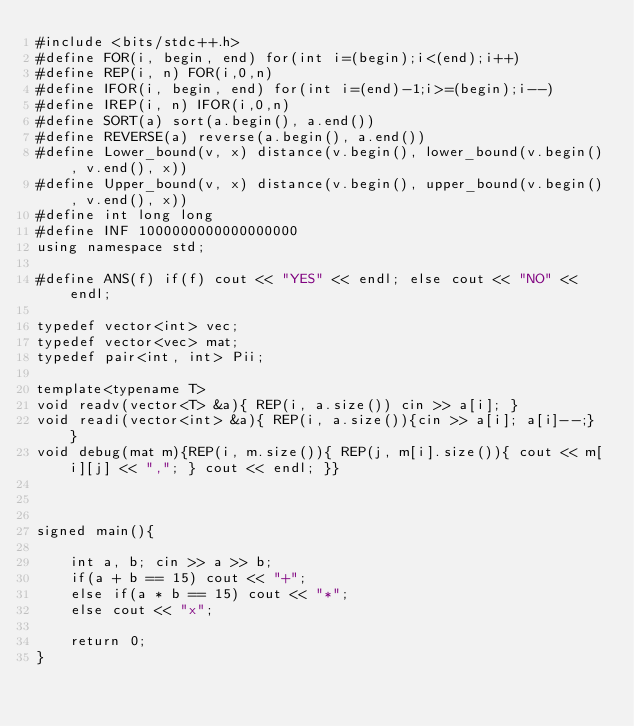Convert code to text. <code><loc_0><loc_0><loc_500><loc_500><_C++_>#include <bits/stdc++.h>
#define FOR(i, begin, end) for(int i=(begin);i<(end);i++)
#define REP(i, n) FOR(i,0,n)
#define IFOR(i, begin, end) for(int i=(end)-1;i>=(begin);i--)
#define IREP(i, n) IFOR(i,0,n)
#define SORT(a) sort(a.begin(), a.end())
#define REVERSE(a) reverse(a.begin(), a.end())
#define Lower_bound(v, x) distance(v.begin(), lower_bound(v.begin(), v.end(), x))
#define Upper_bound(v, x) distance(v.begin(), upper_bound(v.begin(), v.end(), x))
#define int long long
#define INF 1000000000000000000
using namespace std;

#define ANS(f) if(f) cout << "YES" << endl; else cout << "NO" << endl;

typedef vector<int> vec;
typedef vector<vec> mat;
typedef pair<int, int> Pii;

template<typename T>
void readv(vector<T> &a){ REP(i, a.size()) cin >> a[i]; }
void readi(vector<int> &a){ REP(i, a.size()){cin >> a[i]; a[i]--;} }
void debug(mat m){REP(i, m.size()){ REP(j, m[i].size()){ cout << m[i][j] << ","; } cout << endl; }}



signed main(){

    int a, b; cin >> a >> b;
    if(a + b == 15) cout << "+";
    else if(a * b == 15) cout << "*";
    else cout << "x";
    
    return 0;
}</code> 